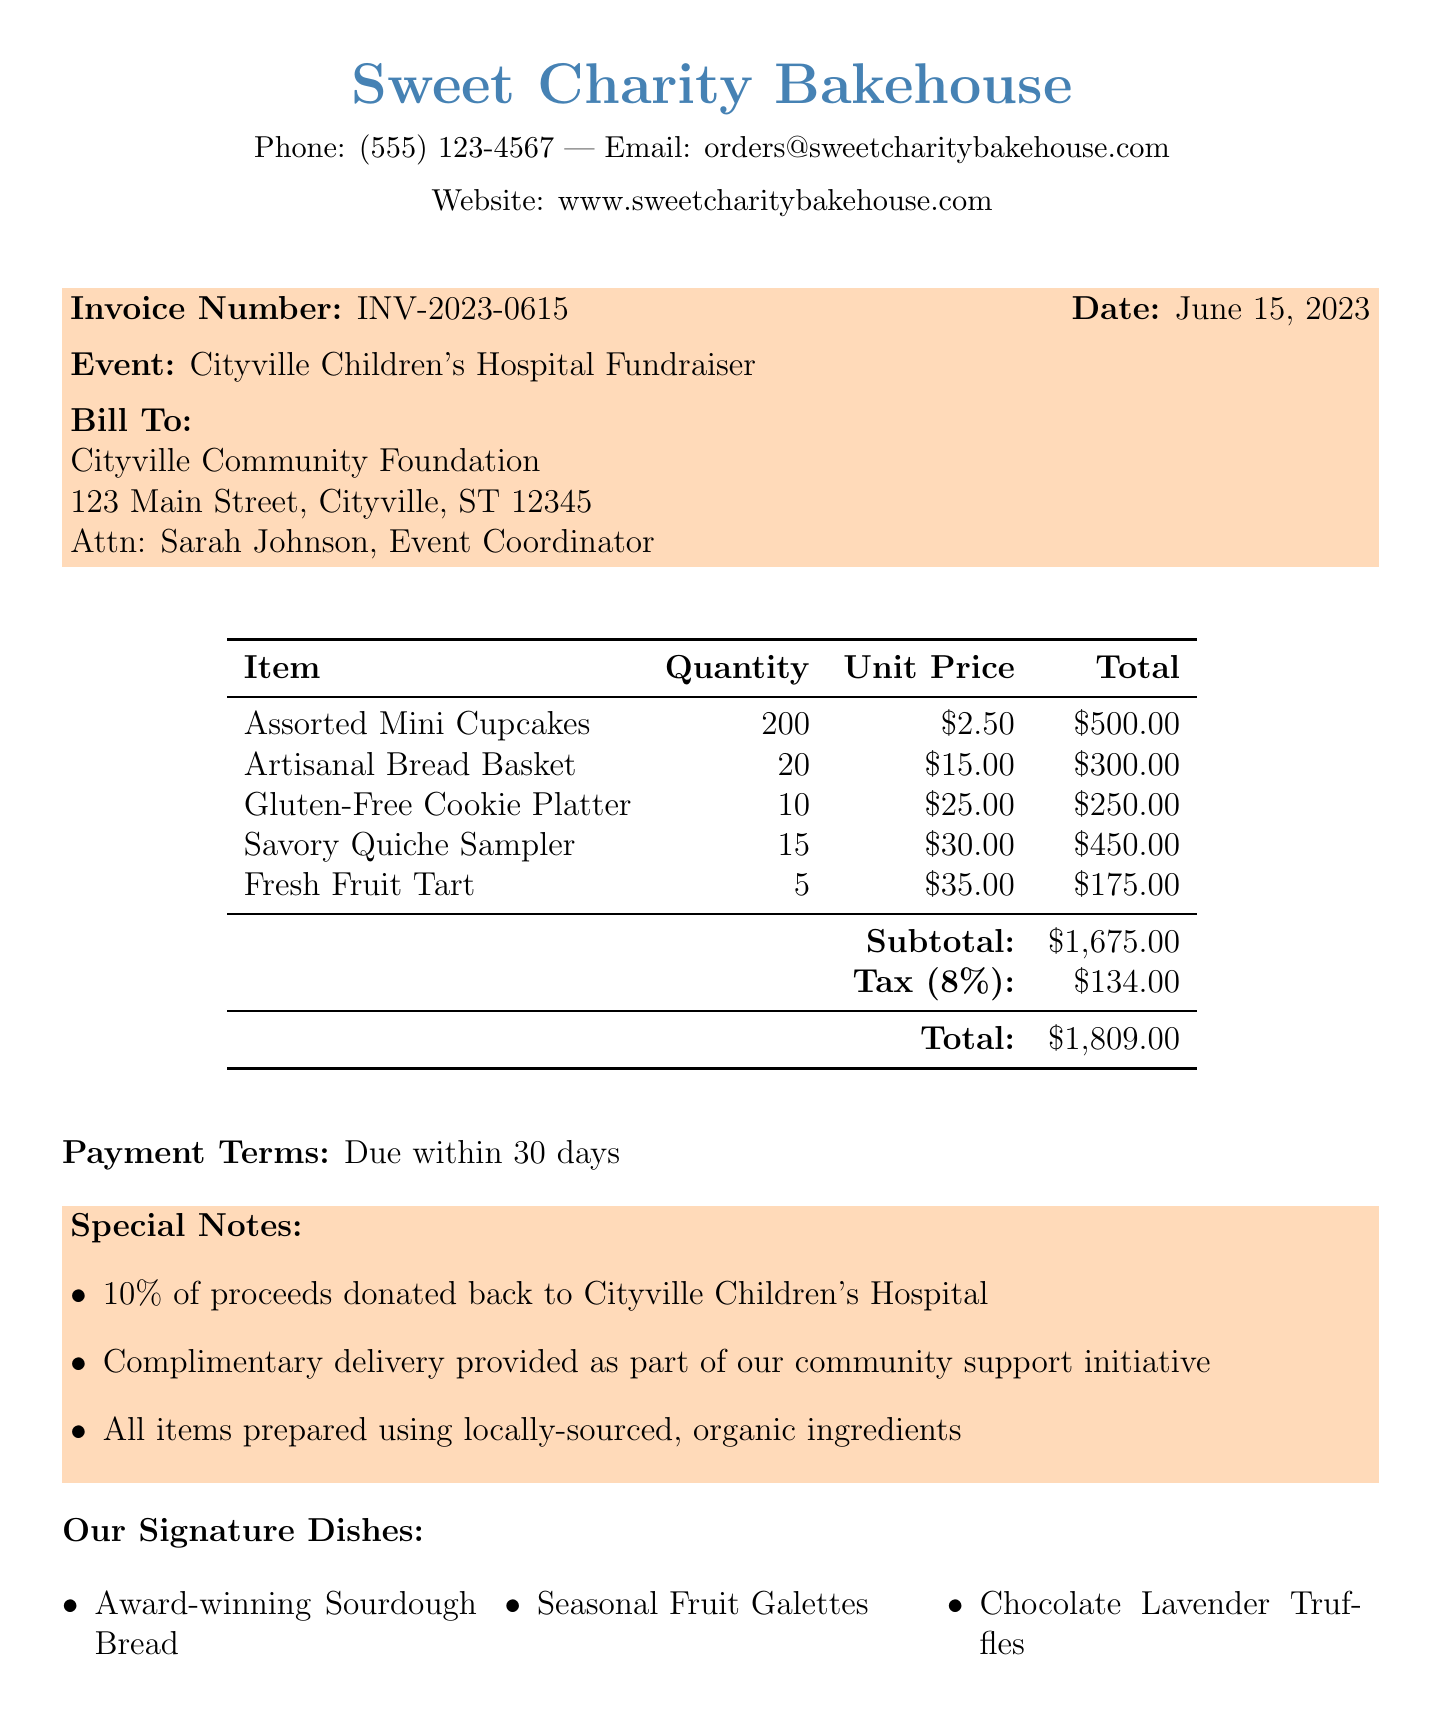What is the bakery's name? The name of the bakery is stated at the top of the document.
Answer: Sweet Charity Bakehouse What is the event date? The event date is mentioned under the event details section.
Answer: June 15, 2023 Who is the contact person for the event? The document specifies the event coordinator's name under the 'Bill To' section.
Answer: Sarah Johnson What is the total amount due on the invoice? The total amount is listed at the end of the invoice calculations.
Answer: $1,809.00 How many assorted mini cupcakes were provided? The quantity of assorted mini cupcakes is indicated in the items list.
Answer: 200 What percentage of proceeds is donated back to the hospital? The special notes section mentions the donation percentage.
Answer: 10% What is included as part of the community support initiative? The special notes section mentions this as complimentary delivery.
Answer: Complimentary delivery How many community involvement initiatives are listed? The document lists multiple initiatives under the community involvement section.
Answer: Three What is the tax rate applied on the invoice? The tax rate is noted in the invoice calculations.
Answer: 8% 